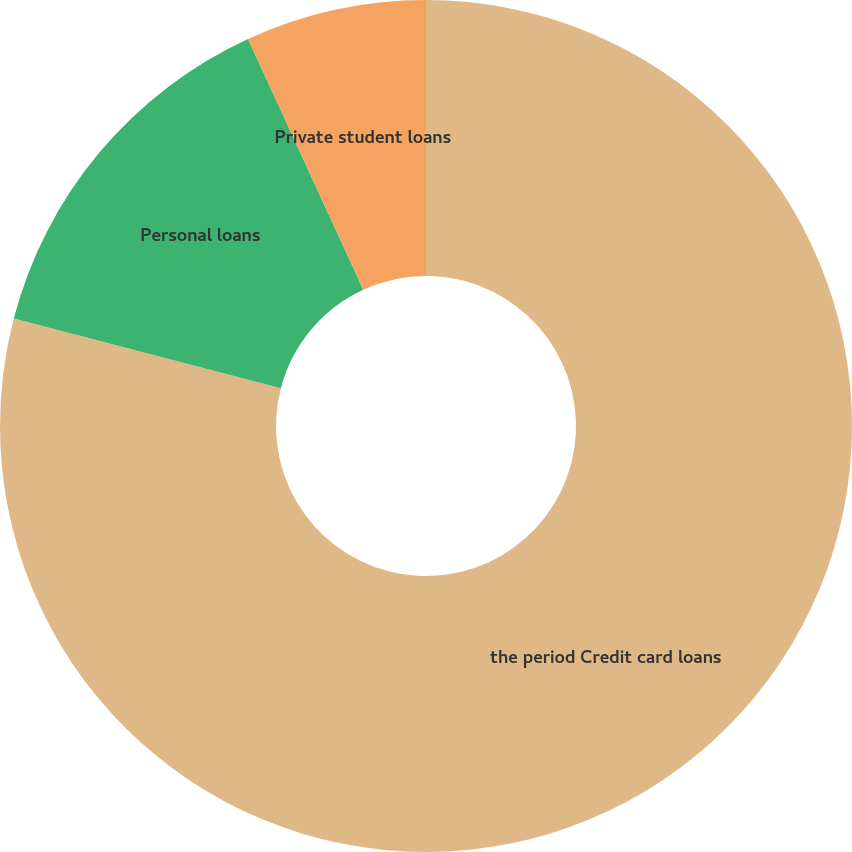<chart> <loc_0><loc_0><loc_500><loc_500><pie_chart><fcel>the period Credit card loans<fcel>Personal loans<fcel>Private student loans<nl><fcel>79.07%<fcel>14.08%<fcel>6.86%<nl></chart> 